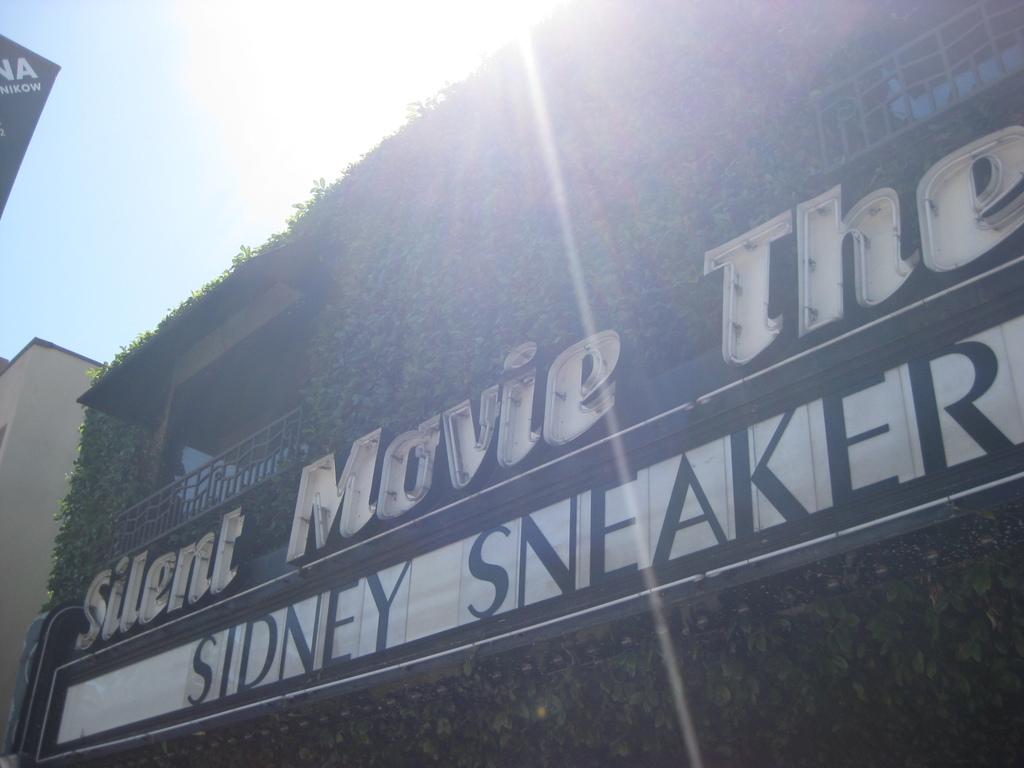What business is that?
Your response must be concise. Silent movie theater. What movie is playing?
Your response must be concise. Sidney sneaker. 